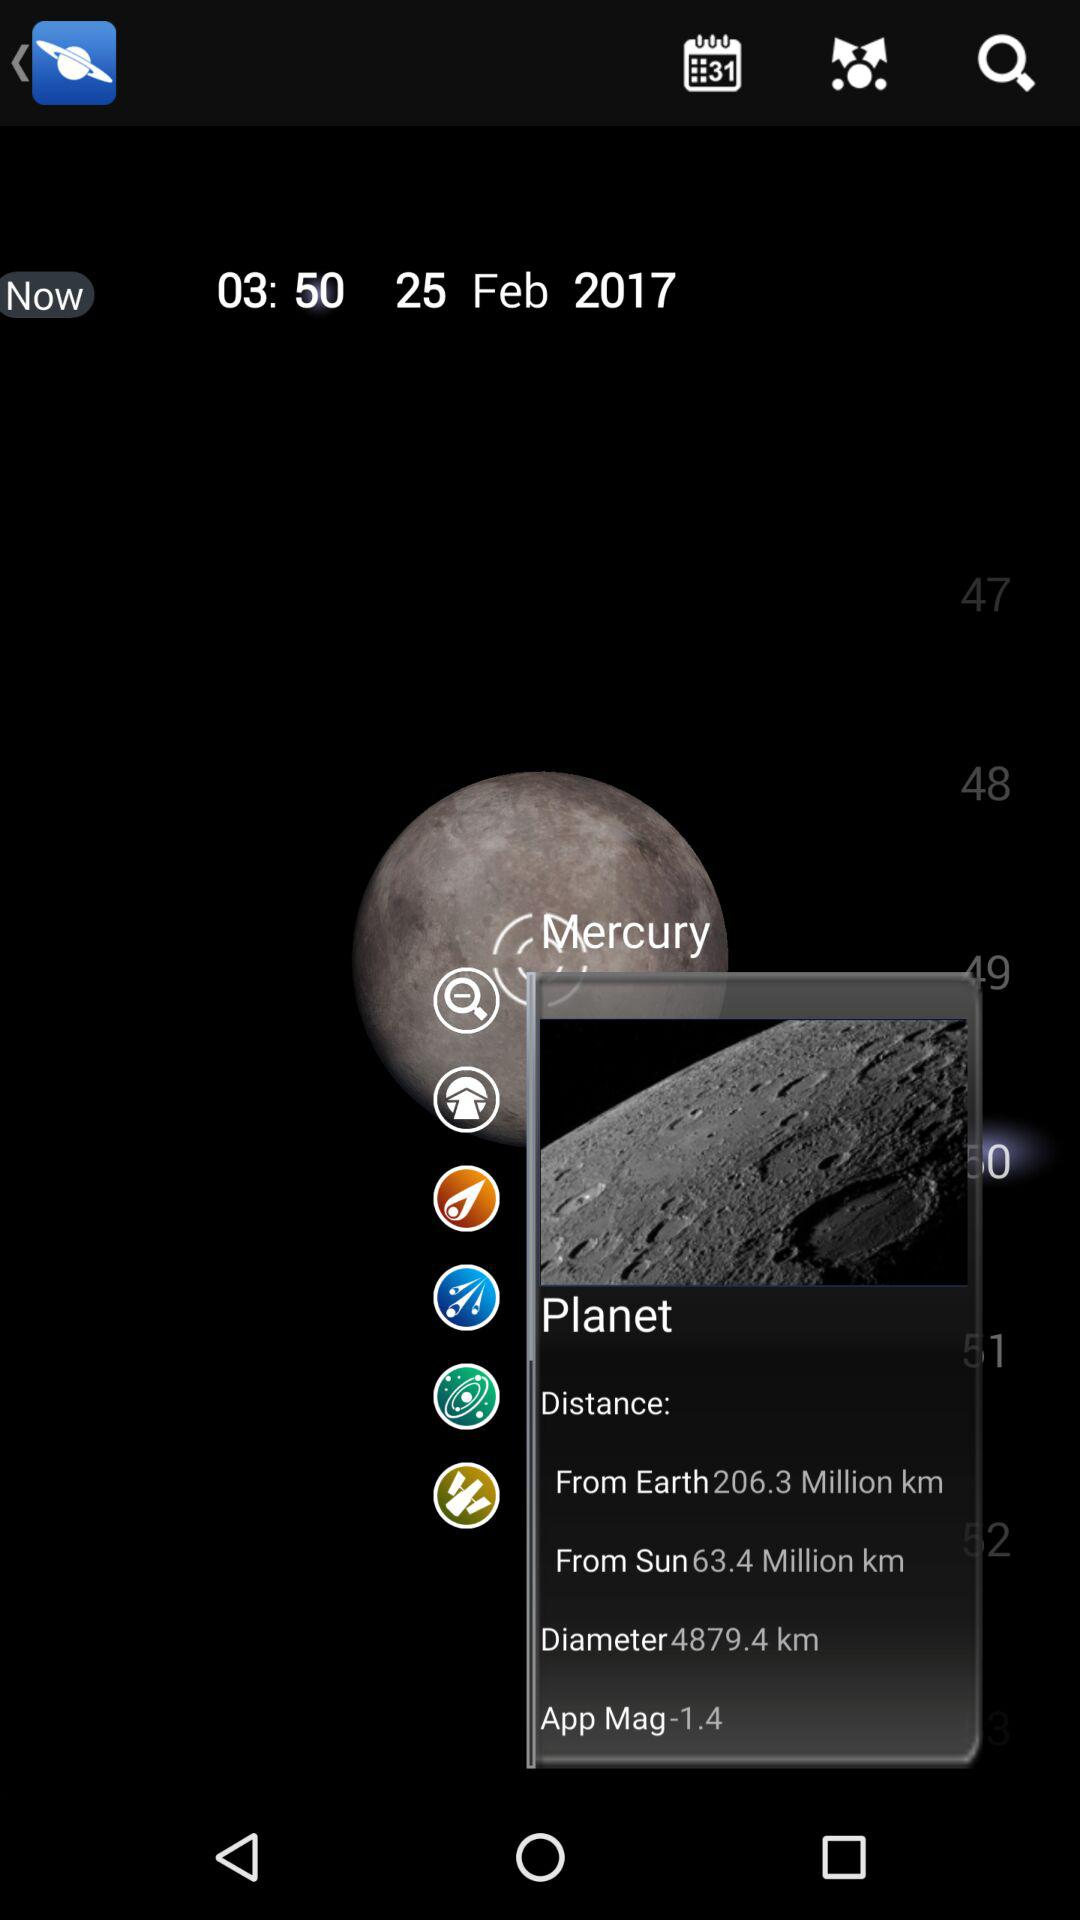What is the distance between "Mercury" and "Earth"? The distance is 206.3 million km. 